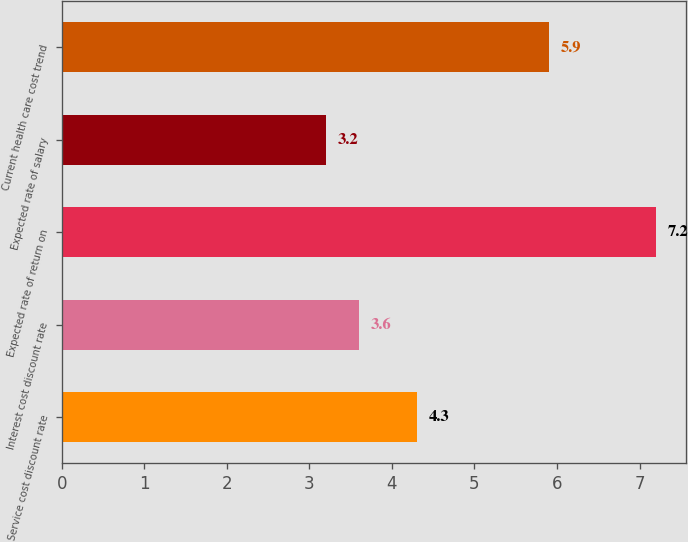<chart> <loc_0><loc_0><loc_500><loc_500><bar_chart><fcel>Service cost discount rate<fcel>Interest cost discount rate<fcel>Expected rate of return on<fcel>Expected rate of salary<fcel>Current health care cost trend<nl><fcel>4.3<fcel>3.6<fcel>7.2<fcel>3.2<fcel>5.9<nl></chart> 